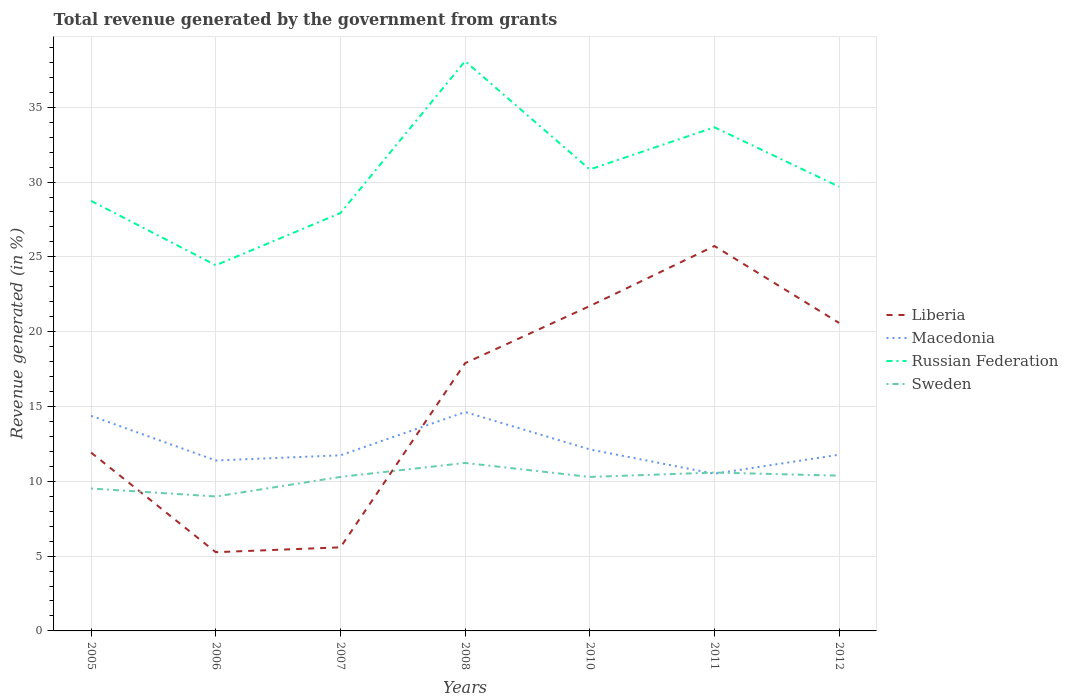Does the line corresponding to Sweden intersect with the line corresponding to Macedonia?
Keep it short and to the point. Yes. Is the number of lines equal to the number of legend labels?
Provide a short and direct response. Yes. Across all years, what is the maximum total revenue generated in Liberia?
Provide a short and direct response. 5.26. What is the total total revenue generated in Macedonia in the graph?
Ensure brevity in your answer.  1.63. What is the difference between the highest and the second highest total revenue generated in Sweden?
Offer a terse response. 2.24. How many lines are there?
Offer a very short reply. 4. What is the difference between two consecutive major ticks on the Y-axis?
Offer a very short reply. 5. Does the graph contain any zero values?
Make the answer very short. No. Does the graph contain grids?
Your response must be concise. Yes. Where does the legend appear in the graph?
Make the answer very short. Center right. How are the legend labels stacked?
Offer a terse response. Vertical. What is the title of the graph?
Ensure brevity in your answer.  Total revenue generated by the government from grants. What is the label or title of the Y-axis?
Offer a very short reply. Revenue generated (in %). What is the Revenue generated (in %) in Liberia in 2005?
Offer a very short reply. 11.92. What is the Revenue generated (in %) in Macedonia in 2005?
Make the answer very short. 14.38. What is the Revenue generated (in %) in Russian Federation in 2005?
Provide a short and direct response. 28.74. What is the Revenue generated (in %) in Sweden in 2005?
Keep it short and to the point. 9.52. What is the Revenue generated (in %) in Liberia in 2006?
Provide a short and direct response. 5.26. What is the Revenue generated (in %) of Macedonia in 2006?
Keep it short and to the point. 11.39. What is the Revenue generated (in %) in Russian Federation in 2006?
Keep it short and to the point. 24.44. What is the Revenue generated (in %) of Sweden in 2006?
Make the answer very short. 8.99. What is the Revenue generated (in %) of Liberia in 2007?
Offer a very short reply. 5.59. What is the Revenue generated (in %) of Macedonia in 2007?
Make the answer very short. 11.74. What is the Revenue generated (in %) of Russian Federation in 2007?
Keep it short and to the point. 27.93. What is the Revenue generated (in %) of Sweden in 2007?
Offer a very short reply. 10.29. What is the Revenue generated (in %) of Liberia in 2008?
Provide a short and direct response. 17.9. What is the Revenue generated (in %) of Macedonia in 2008?
Your response must be concise. 14.63. What is the Revenue generated (in %) in Russian Federation in 2008?
Provide a short and direct response. 38.08. What is the Revenue generated (in %) in Sweden in 2008?
Give a very brief answer. 11.23. What is the Revenue generated (in %) in Liberia in 2010?
Your answer should be compact. 21.71. What is the Revenue generated (in %) of Macedonia in 2010?
Give a very brief answer. 12.13. What is the Revenue generated (in %) of Russian Federation in 2010?
Ensure brevity in your answer.  30.84. What is the Revenue generated (in %) in Sweden in 2010?
Offer a terse response. 10.29. What is the Revenue generated (in %) of Liberia in 2011?
Provide a succinct answer. 25.73. What is the Revenue generated (in %) of Macedonia in 2011?
Provide a short and direct response. 10.51. What is the Revenue generated (in %) of Russian Federation in 2011?
Make the answer very short. 33.66. What is the Revenue generated (in %) in Sweden in 2011?
Make the answer very short. 10.59. What is the Revenue generated (in %) of Liberia in 2012?
Make the answer very short. 20.58. What is the Revenue generated (in %) of Macedonia in 2012?
Offer a very short reply. 11.78. What is the Revenue generated (in %) of Russian Federation in 2012?
Your response must be concise. 29.69. What is the Revenue generated (in %) of Sweden in 2012?
Your answer should be very brief. 10.38. Across all years, what is the maximum Revenue generated (in %) in Liberia?
Provide a succinct answer. 25.73. Across all years, what is the maximum Revenue generated (in %) of Macedonia?
Offer a terse response. 14.63. Across all years, what is the maximum Revenue generated (in %) of Russian Federation?
Your answer should be very brief. 38.08. Across all years, what is the maximum Revenue generated (in %) of Sweden?
Your answer should be compact. 11.23. Across all years, what is the minimum Revenue generated (in %) of Liberia?
Give a very brief answer. 5.26. Across all years, what is the minimum Revenue generated (in %) in Macedonia?
Ensure brevity in your answer.  10.51. Across all years, what is the minimum Revenue generated (in %) of Russian Federation?
Offer a very short reply. 24.44. Across all years, what is the minimum Revenue generated (in %) in Sweden?
Provide a succinct answer. 8.99. What is the total Revenue generated (in %) in Liberia in the graph?
Offer a terse response. 108.69. What is the total Revenue generated (in %) of Macedonia in the graph?
Provide a short and direct response. 86.55. What is the total Revenue generated (in %) of Russian Federation in the graph?
Give a very brief answer. 213.39. What is the total Revenue generated (in %) of Sweden in the graph?
Provide a short and direct response. 71.28. What is the difference between the Revenue generated (in %) of Liberia in 2005 and that in 2006?
Make the answer very short. 6.66. What is the difference between the Revenue generated (in %) of Macedonia in 2005 and that in 2006?
Provide a short and direct response. 2.98. What is the difference between the Revenue generated (in %) in Russian Federation in 2005 and that in 2006?
Offer a very short reply. 4.3. What is the difference between the Revenue generated (in %) in Sweden in 2005 and that in 2006?
Offer a very short reply. 0.53. What is the difference between the Revenue generated (in %) of Liberia in 2005 and that in 2007?
Provide a short and direct response. 6.33. What is the difference between the Revenue generated (in %) of Macedonia in 2005 and that in 2007?
Provide a short and direct response. 2.64. What is the difference between the Revenue generated (in %) in Russian Federation in 2005 and that in 2007?
Provide a succinct answer. 0.82. What is the difference between the Revenue generated (in %) of Sweden in 2005 and that in 2007?
Your answer should be very brief. -0.78. What is the difference between the Revenue generated (in %) of Liberia in 2005 and that in 2008?
Make the answer very short. -5.98. What is the difference between the Revenue generated (in %) in Macedonia in 2005 and that in 2008?
Offer a terse response. -0.25. What is the difference between the Revenue generated (in %) in Russian Federation in 2005 and that in 2008?
Your response must be concise. -9.34. What is the difference between the Revenue generated (in %) of Sweden in 2005 and that in 2008?
Your answer should be compact. -1.71. What is the difference between the Revenue generated (in %) of Liberia in 2005 and that in 2010?
Offer a very short reply. -9.8. What is the difference between the Revenue generated (in %) in Macedonia in 2005 and that in 2010?
Provide a succinct answer. 2.24. What is the difference between the Revenue generated (in %) in Russian Federation in 2005 and that in 2010?
Your answer should be compact. -2.1. What is the difference between the Revenue generated (in %) of Sweden in 2005 and that in 2010?
Ensure brevity in your answer.  -0.77. What is the difference between the Revenue generated (in %) of Liberia in 2005 and that in 2011?
Provide a short and direct response. -13.81. What is the difference between the Revenue generated (in %) in Macedonia in 2005 and that in 2011?
Ensure brevity in your answer.  3.87. What is the difference between the Revenue generated (in %) in Russian Federation in 2005 and that in 2011?
Keep it short and to the point. -4.92. What is the difference between the Revenue generated (in %) in Sweden in 2005 and that in 2011?
Make the answer very short. -1.07. What is the difference between the Revenue generated (in %) of Liberia in 2005 and that in 2012?
Provide a short and direct response. -8.66. What is the difference between the Revenue generated (in %) in Macedonia in 2005 and that in 2012?
Ensure brevity in your answer.  2.6. What is the difference between the Revenue generated (in %) in Russian Federation in 2005 and that in 2012?
Keep it short and to the point. -0.94. What is the difference between the Revenue generated (in %) of Sweden in 2005 and that in 2012?
Offer a very short reply. -0.86. What is the difference between the Revenue generated (in %) of Liberia in 2006 and that in 2007?
Keep it short and to the point. -0.33. What is the difference between the Revenue generated (in %) in Macedonia in 2006 and that in 2007?
Your answer should be compact. -0.35. What is the difference between the Revenue generated (in %) of Russian Federation in 2006 and that in 2007?
Provide a succinct answer. -3.49. What is the difference between the Revenue generated (in %) in Sweden in 2006 and that in 2007?
Offer a very short reply. -1.31. What is the difference between the Revenue generated (in %) of Liberia in 2006 and that in 2008?
Provide a short and direct response. -12.63. What is the difference between the Revenue generated (in %) in Macedonia in 2006 and that in 2008?
Keep it short and to the point. -3.24. What is the difference between the Revenue generated (in %) in Russian Federation in 2006 and that in 2008?
Ensure brevity in your answer.  -13.64. What is the difference between the Revenue generated (in %) of Sweden in 2006 and that in 2008?
Provide a succinct answer. -2.24. What is the difference between the Revenue generated (in %) of Liberia in 2006 and that in 2010?
Your answer should be compact. -16.45. What is the difference between the Revenue generated (in %) of Macedonia in 2006 and that in 2010?
Provide a short and direct response. -0.74. What is the difference between the Revenue generated (in %) of Russian Federation in 2006 and that in 2010?
Ensure brevity in your answer.  -6.4. What is the difference between the Revenue generated (in %) in Sweden in 2006 and that in 2010?
Make the answer very short. -1.31. What is the difference between the Revenue generated (in %) in Liberia in 2006 and that in 2011?
Ensure brevity in your answer.  -20.46. What is the difference between the Revenue generated (in %) of Macedonia in 2006 and that in 2011?
Ensure brevity in your answer.  0.89. What is the difference between the Revenue generated (in %) of Russian Federation in 2006 and that in 2011?
Your answer should be compact. -9.22. What is the difference between the Revenue generated (in %) of Sweden in 2006 and that in 2011?
Offer a very short reply. -1.6. What is the difference between the Revenue generated (in %) of Liberia in 2006 and that in 2012?
Ensure brevity in your answer.  -15.32. What is the difference between the Revenue generated (in %) in Macedonia in 2006 and that in 2012?
Your answer should be compact. -0.39. What is the difference between the Revenue generated (in %) in Russian Federation in 2006 and that in 2012?
Provide a short and direct response. -5.25. What is the difference between the Revenue generated (in %) in Sweden in 2006 and that in 2012?
Make the answer very short. -1.39. What is the difference between the Revenue generated (in %) of Liberia in 2007 and that in 2008?
Give a very brief answer. -12.31. What is the difference between the Revenue generated (in %) in Macedonia in 2007 and that in 2008?
Provide a succinct answer. -2.89. What is the difference between the Revenue generated (in %) in Russian Federation in 2007 and that in 2008?
Keep it short and to the point. -10.16. What is the difference between the Revenue generated (in %) in Sweden in 2007 and that in 2008?
Provide a short and direct response. -0.93. What is the difference between the Revenue generated (in %) of Liberia in 2007 and that in 2010?
Provide a short and direct response. -16.13. What is the difference between the Revenue generated (in %) of Macedonia in 2007 and that in 2010?
Offer a very short reply. -0.39. What is the difference between the Revenue generated (in %) of Russian Federation in 2007 and that in 2010?
Offer a terse response. -2.92. What is the difference between the Revenue generated (in %) in Sweden in 2007 and that in 2010?
Your answer should be very brief. 0. What is the difference between the Revenue generated (in %) in Liberia in 2007 and that in 2011?
Ensure brevity in your answer.  -20.14. What is the difference between the Revenue generated (in %) in Macedonia in 2007 and that in 2011?
Make the answer very short. 1.23. What is the difference between the Revenue generated (in %) of Russian Federation in 2007 and that in 2011?
Offer a terse response. -5.73. What is the difference between the Revenue generated (in %) in Sweden in 2007 and that in 2011?
Keep it short and to the point. -0.29. What is the difference between the Revenue generated (in %) of Liberia in 2007 and that in 2012?
Offer a very short reply. -15. What is the difference between the Revenue generated (in %) in Macedonia in 2007 and that in 2012?
Your response must be concise. -0.04. What is the difference between the Revenue generated (in %) of Russian Federation in 2007 and that in 2012?
Your response must be concise. -1.76. What is the difference between the Revenue generated (in %) of Sweden in 2007 and that in 2012?
Offer a very short reply. -0.08. What is the difference between the Revenue generated (in %) of Liberia in 2008 and that in 2010?
Provide a succinct answer. -3.82. What is the difference between the Revenue generated (in %) of Macedonia in 2008 and that in 2010?
Keep it short and to the point. 2.5. What is the difference between the Revenue generated (in %) in Russian Federation in 2008 and that in 2010?
Keep it short and to the point. 7.24. What is the difference between the Revenue generated (in %) of Sweden in 2008 and that in 2010?
Offer a terse response. 0.94. What is the difference between the Revenue generated (in %) in Liberia in 2008 and that in 2011?
Ensure brevity in your answer.  -7.83. What is the difference between the Revenue generated (in %) of Macedonia in 2008 and that in 2011?
Provide a succinct answer. 4.12. What is the difference between the Revenue generated (in %) of Russian Federation in 2008 and that in 2011?
Make the answer very short. 4.42. What is the difference between the Revenue generated (in %) in Sweden in 2008 and that in 2011?
Keep it short and to the point. 0.64. What is the difference between the Revenue generated (in %) in Liberia in 2008 and that in 2012?
Make the answer very short. -2.69. What is the difference between the Revenue generated (in %) in Macedonia in 2008 and that in 2012?
Offer a very short reply. 2.85. What is the difference between the Revenue generated (in %) in Russian Federation in 2008 and that in 2012?
Your answer should be very brief. 8.4. What is the difference between the Revenue generated (in %) of Liberia in 2010 and that in 2011?
Keep it short and to the point. -4.01. What is the difference between the Revenue generated (in %) of Macedonia in 2010 and that in 2011?
Offer a very short reply. 1.63. What is the difference between the Revenue generated (in %) of Russian Federation in 2010 and that in 2011?
Your answer should be very brief. -2.82. What is the difference between the Revenue generated (in %) of Sweden in 2010 and that in 2011?
Keep it short and to the point. -0.29. What is the difference between the Revenue generated (in %) of Liberia in 2010 and that in 2012?
Keep it short and to the point. 1.13. What is the difference between the Revenue generated (in %) of Macedonia in 2010 and that in 2012?
Your answer should be compact. 0.35. What is the difference between the Revenue generated (in %) of Russian Federation in 2010 and that in 2012?
Keep it short and to the point. 1.16. What is the difference between the Revenue generated (in %) in Sweden in 2010 and that in 2012?
Offer a very short reply. -0.09. What is the difference between the Revenue generated (in %) of Liberia in 2011 and that in 2012?
Your answer should be compact. 5.14. What is the difference between the Revenue generated (in %) in Macedonia in 2011 and that in 2012?
Ensure brevity in your answer.  -1.27. What is the difference between the Revenue generated (in %) in Russian Federation in 2011 and that in 2012?
Provide a short and direct response. 3.98. What is the difference between the Revenue generated (in %) in Sweden in 2011 and that in 2012?
Your response must be concise. 0.21. What is the difference between the Revenue generated (in %) in Liberia in 2005 and the Revenue generated (in %) in Macedonia in 2006?
Offer a very short reply. 0.53. What is the difference between the Revenue generated (in %) in Liberia in 2005 and the Revenue generated (in %) in Russian Federation in 2006?
Offer a terse response. -12.52. What is the difference between the Revenue generated (in %) of Liberia in 2005 and the Revenue generated (in %) of Sweden in 2006?
Provide a short and direct response. 2.93. What is the difference between the Revenue generated (in %) of Macedonia in 2005 and the Revenue generated (in %) of Russian Federation in 2006?
Make the answer very short. -10.06. What is the difference between the Revenue generated (in %) in Macedonia in 2005 and the Revenue generated (in %) in Sweden in 2006?
Offer a terse response. 5.39. What is the difference between the Revenue generated (in %) of Russian Federation in 2005 and the Revenue generated (in %) of Sweden in 2006?
Your answer should be very brief. 19.76. What is the difference between the Revenue generated (in %) of Liberia in 2005 and the Revenue generated (in %) of Macedonia in 2007?
Make the answer very short. 0.18. What is the difference between the Revenue generated (in %) in Liberia in 2005 and the Revenue generated (in %) in Russian Federation in 2007?
Give a very brief answer. -16.01. What is the difference between the Revenue generated (in %) in Liberia in 2005 and the Revenue generated (in %) in Sweden in 2007?
Provide a short and direct response. 1.63. What is the difference between the Revenue generated (in %) in Macedonia in 2005 and the Revenue generated (in %) in Russian Federation in 2007?
Offer a very short reply. -13.55. What is the difference between the Revenue generated (in %) of Macedonia in 2005 and the Revenue generated (in %) of Sweden in 2007?
Provide a succinct answer. 4.08. What is the difference between the Revenue generated (in %) of Russian Federation in 2005 and the Revenue generated (in %) of Sweden in 2007?
Provide a succinct answer. 18.45. What is the difference between the Revenue generated (in %) in Liberia in 2005 and the Revenue generated (in %) in Macedonia in 2008?
Make the answer very short. -2.71. What is the difference between the Revenue generated (in %) of Liberia in 2005 and the Revenue generated (in %) of Russian Federation in 2008?
Offer a very short reply. -26.16. What is the difference between the Revenue generated (in %) of Liberia in 2005 and the Revenue generated (in %) of Sweden in 2008?
Your response must be concise. 0.69. What is the difference between the Revenue generated (in %) in Macedonia in 2005 and the Revenue generated (in %) in Russian Federation in 2008?
Your answer should be compact. -23.71. What is the difference between the Revenue generated (in %) in Macedonia in 2005 and the Revenue generated (in %) in Sweden in 2008?
Provide a short and direct response. 3.15. What is the difference between the Revenue generated (in %) of Russian Federation in 2005 and the Revenue generated (in %) of Sweden in 2008?
Offer a very short reply. 17.52. What is the difference between the Revenue generated (in %) of Liberia in 2005 and the Revenue generated (in %) of Macedonia in 2010?
Provide a short and direct response. -0.21. What is the difference between the Revenue generated (in %) of Liberia in 2005 and the Revenue generated (in %) of Russian Federation in 2010?
Give a very brief answer. -18.93. What is the difference between the Revenue generated (in %) in Liberia in 2005 and the Revenue generated (in %) in Sweden in 2010?
Your response must be concise. 1.63. What is the difference between the Revenue generated (in %) of Macedonia in 2005 and the Revenue generated (in %) of Russian Federation in 2010?
Give a very brief answer. -16.47. What is the difference between the Revenue generated (in %) in Macedonia in 2005 and the Revenue generated (in %) in Sweden in 2010?
Your response must be concise. 4.08. What is the difference between the Revenue generated (in %) of Russian Federation in 2005 and the Revenue generated (in %) of Sweden in 2010?
Your answer should be compact. 18.45. What is the difference between the Revenue generated (in %) in Liberia in 2005 and the Revenue generated (in %) in Macedonia in 2011?
Provide a succinct answer. 1.41. What is the difference between the Revenue generated (in %) of Liberia in 2005 and the Revenue generated (in %) of Russian Federation in 2011?
Give a very brief answer. -21.74. What is the difference between the Revenue generated (in %) of Liberia in 2005 and the Revenue generated (in %) of Sweden in 2011?
Offer a very short reply. 1.33. What is the difference between the Revenue generated (in %) in Macedonia in 2005 and the Revenue generated (in %) in Russian Federation in 2011?
Offer a terse response. -19.29. What is the difference between the Revenue generated (in %) of Macedonia in 2005 and the Revenue generated (in %) of Sweden in 2011?
Give a very brief answer. 3.79. What is the difference between the Revenue generated (in %) in Russian Federation in 2005 and the Revenue generated (in %) in Sweden in 2011?
Your response must be concise. 18.16. What is the difference between the Revenue generated (in %) in Liberia in 2005 and the Revenue generated (in %) in Macedonia in 2012?
Your response must be concise. 0.14. What is the difference between the Revenue generated (in %) in Liberia in 2005 and the Revenue generated (in %) in Russian Federation in 2012?
Offer a terse response. -17.77. What is the difference between the Revenue generated (in %) in Liberia in 2005 and the Revenue generated (in %) in Sweden in 2012?
Your answer should be compact. 1.54. What is the difference between the Revenue generated (in %) in Macedonia in 2005 and the Revenue generated (in %) in Russian Federation in 2012?
Offer a terse response. -15.31. What is the difference between the Revenue generated (in %) in Macedonia in 2005 and the Revenue generated (in %) in Sweden in 2012?
Offer a terse response. 4. What is the difference between the Revenue generated (in %) of Russian Federation in 2005 and the Revenue generated (in %) of Sweden in 2012?
Keep it short and to the point. 18.37. What is the difference between the Revenue generated (in %) of Liberia in 2006 and the Revenue generated (in %) of Macedonia in 2007?
Give a very brief answer. -6.48. What is the difference between the Revenue generated (in %) of Liberia in 2006 and the Revenue generated (in %) of Russian Federation in 2007?
Your response must be concise. -22.67. What is the difference between the Revenue generated (in %) in Liberia in 2006 and the Revenue generated (in %) in Sweden in 2007?
Provide a short and direct response. -5.03. What is the difference between the Revenue generated (in %) in Macedonia in 2006 and the Revenue generated (in %) in Russian Federation in 2007?
Your response must be concise. -16.54. What is the difference between the Revenue generated (in %) in Macedonia in 2006 and the Revenue generated (in %) in Sweden in 2007?
Offer a very short reply. 1.1. What is the difference between the Revenue generated (in %) of Russian Federation in 2006 and the Revenue generated (in %) of Sweden in 2007?
Make the answer very short. 14.15. What is the difference between the Revenue generated (in %) of Liberia in 2006 and the Revenue generated (in %) of Macedonia in 2008?
Your answer should be compact. -9.37. What is the difference between the Revenue generated (in %) of Liberia in 2006 and the Revenue generated (in %) of Russian Federation in 2008?
Provide a short and direct response. -32.82. What is the difference between the Revenue generated (in %) of Liberia in 2006 and the Revenue generated (in %) of Sweden in 2008?
Your response must be concise. -5.97. What is the difference between the Revenue generated (in %) in Macedonia in 2006 and the Revenue generated (in %) in Russian Federation in 2008?
Ensure brevity in your answer.  -26.69. What is the difference between the Revenue generated (in %) of Macedonia in 2006 and the Revenue generated (in %) of Sweden in 2008?
Your answer should be very brief. 0.16. What is the difference between the Revenue generated (in %) of Russian Federation in 2006 and the Revenue generated (in %) of Sweden in 2008?
Your response must be concise. 13.21. What is the difference between the Revenue generated (in %) of Liberia in 2006 and the Revenue generated (in %) of Macedonia in 2010?
Offer a terse response. -6.87. What is the difference between the Revenue generated (in %) of Liberia in 2006 and the Revenue generated (in %) of Russian Federation in 2010?
Your answer should be very brief. -25.58. What is the difference between the Revenue generated (in %) of Liberia in 2006 and the Revenue generated (in %) of Sweden in 2010?
Provide a succinct answer. -5.03. What is the difference between the Revenue generated (in %) in Macedonia in 2006 and the Revenue generated (in %) in Russian Federation in 2010?
Offer a terse response. -19.45. What is the difference between the Revenue generated (in %) in Macedonia in 2006 and the Revenue generated (in %) in Sweden in 2010?
Provide a short and direct response. 1.1. What is the difference between the Revenue generated (in %) in Russian Federation in 2006 and the Revenue generated (in %) in Sweden in 2010?
Ensure brevity in your answer.  14.15. What is the difference between the Revenue generated (in %) of Liberia in 2006 and the Revenue generated (in %) of Macedonia in 2011?
Offer a very short reply. -5.24. What is the difference between the Revenue generated (in %) in Liberia in 2006 and the Revenue generated (in %) in Russian Federation in 2011?
Keep it short and to the point. -28.4. What is the difference between the Revenue generated (in %) of Liberia in 2006 and the Revenue generated (in %) of Sweden in 2011?
Your answer should be very brief. -5.32. What is the difference between the Revenue generated (in %) of Macedonia in 2006 and the Revenue generated (in %) of Russian Federation in 2011?
Your answer should be very brief. -22.27. What is the difference between the Revenue generated (in %) in Macedonia in 2006 and the Revenue generated (in %) in Sweden in 2011?
Make the answer very short. 0.81. What is the difference between the Revenue generated (in %) of Russian Federation in 2006 and the Revenue generated (in %) of Sweden in 2011?
Give a very brief answer. 13.86. What is the difference between the Revenue generated (in %) of Liberia in 2006 and the Revenue generated (in %) of Macedonia in 2012?
Ensure brevity in your answer.  -6.52. What is the difference between the Revenue generated (in %) in Liberia in 2006 and the Revenue generated (in %) in Russian Federation in 2012?
Give a very brief answer. -24.42. What is the difference between the Revenue generated (in %) in Liberia in 2006 and the Revenue generated (in %) in Sweden in 2012?
Your answer should be very brief. -5.12. What is the difference between the Revenue generated (in %) of Macedonia in 2006 and the Revenue generated (in %) of Russian Federation in 2012?
Offer a terse response. -18.29. What is the difference between the Revenue generated (in %) of Macedonia in 2006 and the Revenue generated (in %) of Sweden in 2012?
Offer a terse response. 1.01. What is the difference between the Revenue generated (in %) in Russian Federation in 2006 and the Revenue generated (in %) in Sweden in 2012?
Offer a terse response. 14.06. What is the difference between the Revenue generated (in %) of Liberia in 2007 and the Revenue generated (in %) of Macedonia in 2008?
Provide a succinct answer. -9.04. What is the difference between the Revenue generated (in %) of Liberia in 2007 and the Revenue generated (in %) of Russian Federation in 2008?
Offer a terse response. -32.5. What is the difference between the Revenue generated (in %) in Liberia in 2007 and the Revenue generated (in %) in Sweden in 2008?
Make the answer very short. -5.64. What is the difference between the Revenue generated (in %) of Macedonia in 2007 and the Revenue generated (in %) of Russian Federation in 2008?
Your answer should be very brief. -26.35. What is the difference between the Revenue generated (in %) of Macedonia in 2007 and the Revenue generated (in %) of Sweden in 2008?
Your response must be concise. 0.51. What is the difference between the Revenue generated (in %) in Russian Federation in 2007 and the Revenue generated (in %) in Sweden in 2008?
Make the answer very short. 16.7. What is the difference between the Revenue generated (in %) of Liberia in 2007 and the Revenue generated (in %) of Macedonia in 2010?
Your answer should be very brief. -6.54. What is the difference between the Revenue generated (in %) in Liberia in 2007 and the Revenue generated (in %) in Russian Federation in 2010?
Your response must be concise. -25.26. What is the difference between the Revenue generated (in %) in Liberia in 2007 and the Revenue generated (in %) in Sweden in 2010?
Your answer should be very brief. -4.7. What is the difference between the Revenue generated (in %) in Macedonia in 2007 and the Revenue generated (in %) in Russian Federation in 2010?
Your answer should be very brief. -19.11. What is the difference between the Revenue generated (in %) of Macedonia in 2007 and the Revenue generated (in %) of Sweden in 2010?
Make the answer very short. 1.45. What is the difference between the Revenue generated (in %) of Russian Federation in 2007 and the Revenue generated (in %) of Sweden in 2010?
Offer a very short reply. 17.64. What is the difference between the Revenue generated (in %) of Liberia in 2007 and the Revenue generated (in %) of Macedonia in 2011?
Give a very brief answer. -4.92. What is the difference between the Revenue generated (in %) in Liberia in 2007 and the Revenue generated (in %) in Russian Federation in 2011?
Provide a succinct answer. -28.08. What is the difference between the Revenue generated (in %) in Liberia in 2007 and the Revenue generated (in %) in Sweden in 2011?
Your response must be concise. -5. What is the difference between the Revenue generated (in %) in Macedonia in 2007 and the Revenue generated (in %) in Russian Federation in 2011?
Your response must be concise. -21.93. What is the difference between the Revenue generated (in %) of Macedonia in 2007 and the Revenue generated (in %) of Sweden in 2011?
Give a very brief answer. 1.15. What is the difference between the Revenue generated (in %) of Russian Federation in 2007 and the Revenue generated (in %) of Sweden in 2011?
Provide a succinct answer. 17.34. What is the difference between the Revenue generated (in %) of Liberia in 2007 and the Revenue generated (in %) of Macedonia in 2012?
Provide a short and direct response. -6.19. What is the difference between the Revenue generated (in %) of Liberia in 2007 and the Revenue generated (in %) of Russian Federation in 2012?
Make the answer very short. -24.1. What is the difference between the Revenue generated (in %) in Liberia in 2007 and the Revenue generated (in %) in Sweden in 2012?
Give a very brief answer. -4.79. What is the difference between the Revenue generated (in %) in Macedonia in 2007 and the Revenue generated (in %) in Russian Federation in 2012?
Keep it short and to the point. -17.95. What is the difference between the Revenue generated (in %) in Macedonia in 2007 and the Revenue generated (in %) in Sweden in 2012?
Make the answer very short. 1.36. What is the difference between the Revenue generated (in %) in Russian Federation in 2007 and the Revenue generated (in %) in Sweden in 2012?
Ensure brevity in your answer.  17.55. What is the difference between the Revenue generated (in %) in Liberia in 2008 and the Revenue generated (in %) in Macedonia in 2010?
Your answer should be very brief. 5.76. What is the difference between the Revenue generated (in %) of Liberia in 2008 and the Revenue generated (in %) of Russian Federation in 2010?
Your response must be concise. -12.95. What is the difference between the Revenue generated (in %) in Liberia in 2008 and the Revenue generated (in %) in Sweden in 2010?
Offer a very short reply. 7.61. What is the difference between the Revenue generated (in %) in Macedonia in 2008 and the Revenue generated (in %) in Russian Federation in 2010?
Make the answer very short. -16.21. What is the difference between the Revenue generated (in %) of Macedonia in 2008 and the Revenue generated (in %) of Sweden in 2010?
Your answer should be compact. 4.34. What is the difference between the Revenue generated (in %) of Russian Federation in 2008 and the Revenue generated (in %) of Sweden in 2010?
Ensure brevity in your answer.  27.79. What is the difference between the Revenue generated (in %) of Liberia in 2008 and the Revenue generated (in %) of Macedonia in 2011?
Offer a terse response. 7.39. What is the difference between the Revenue generated (in %) of Liberia in 2008 and the Revenue generated (in %) of Russian Federation in 2011?
Make the answer very short. -15.77. What is the difference between the Revenue generated (in %) in Liberia in 2008 and the Revenue generated (in %) in Sweden in 2011?
Provide a succinct answer. 7.31. What is the difference between the Revenue generated (in %) of Macedonia in 2008 and the Revenue generated (in %) of Russian Federation in 2011?
Offer a very short reply. -19.03. What is the difference between the Revenue generated (in %) in Macedonia in 2008 and the Revenue generated (in %) in Sweden in 2011?
Make the answer very short. 4.05. What is the difference between the Revenue generated (in %) of Russian Federation in 2008 and the Revenue generated (in %) of Sweden in 2011?
Keep it short and to the point. 27.5. What is the difference between the Revenue generated (in %) in Liberia in 2008 and the Revenue generated (in %) in Macedonia in 2012?
Offer a very short reply. 6.12. What is the difference between the Revenue generated (in %) of Liberia in 2008 and the Revenue generated (in %) of Russian Federation in 2012?
Provide a succinct answer. -11.79. What is the difference between the Revenue generated (in %) in Liberia in 2008 and the Revenue generated (in %) in Sweden in 2012?
Your response must be concise. 7.52. What is the difference between the Revenue generated (in %) of Macedonia in 2008 and the Revenue generated (in %) of Russian Federation in 2012?
Offer a terse response. -15.06. What is the difference between the Revenue generated (in %) of Macedonia in 2008 and the Revenue generated (in %) of Sweden in 2012?
Give a very brief answer. 4.25. What is the difference between the Revenue generated (in %) in Russian Federation in 2008 and the Revenue generated (in %) in Sweden in 2012?
Provide a short and direct response. 27.71. What is the difference between the Revenue generated (in %) in Liberia in 2010 and the Revenue generated (in %) in Macedonia in 2011?
Provide a succinct answer. 11.21. What is the difference between the Revenue generated (in %) of Liberia in 2010 and the Revenue generated (in %) of Russian Federation in 2011?
Ensure brevity in your answer.  -11.95. What is the difference between the Revenue generated (in %) of Liberia in 2010 and the Revenue generated (in %) of Sweden in 2011?
Give a very brief answer. 11.13. What is the difference between the Revenue generated (in %) of Macedonia in 2010 and the Revenue generated (in %) of Russian Federation in 2011?
Provide a short and direct response. -21.53. What is the difference between the Revenue generated (in %) in Macedonia in 2010 and the Revenue generated (in %) in Sweden in 2011?
Provide a succinct answer. 1.55. What is the difference between the Revenue generated (in %) of Russian Federation in 2010 and the Revenue generated (in %) of Sweden in 2011?
Provide a short and direct response. 20.26. What is the difference between the Revenue generated (in %) of Liberia in 2010 and the Revenue generated (in %) of Macedonia in 2012?
Keep it short and to the point. 9.94. What is the difference between the Revenue generated (in %) of Liberia in 2010 and the Revenue generated (in %) of Russian Federation in 2012?
Your answer should be compact. -7.97. What is the difference between the Revenue generated (in %) in Liberia in 2010 and the Revenue generated (in %) in Sweden in 2012?
Make the answer very short. 11.34. What is the difference between the Revenue generated (in %) in Macedonia in 2010 and the Revenue generated (in %) in Russian Federation in 2012?
Give a very brief answer. -17.56. What is the difference between the Revenue generated (in %) in Macedonia in 2010 and the Revenue generated (in %) in Sweden in 2012?
Give a very brief answer. 1.75. What is the difference between the Revenue generated (in %) in Russian Federation in 2010 and the Revenue generated (in %) in Sweden in 2012?
Provide a short and direct response. 20.47. What is the difference between the Revenue generated (in %) in Liberia in 2011 and the Revenue generated (in %) in Macedonia in 2012?
Offer a terse response. 13.95. What is the difference between the Revenue generated (in %) in Liberia in 2011 and the Revenue generated (in %) in Russian Federation in 2012?
Provide a short and direct response. -3.96. What is the difference between the Revenue generated (in %) of Liberia in 2011 and the Revenue generated (in %) of Sweden in 2012?
Your answer should be compact. 15.35. What is the difference between the Revenue generated (in %) of Macedonia in 2011 and the Revenue generated (in %) of Russian Federation in 2012?
Keep it short and to the point. -19.18. What is the difference between the Revenue generated (in %) in Macedonia in 2011 and the Revenue generated (in %) in Sweden in 2012?
Offer a very short reply. 0.13. What is the difference between the Revenue generated (in %) in Russian Federation in 2011 and the Revenue generated (in %) in Sweden in 2012?
Your answer should be compact. 23.29. What is the average Revenue generated (in %) in Liberia per year?
Keep it short and to the point. 15.53. What is the average Revenue generated (in %) in Macedonia per year?
Offer a terse response. 12.36. What is the average Revenue generated (in %) in Russian Federation per year?
Your answer should be compact. 30.48. What is the average Revenue generated (in %) of Sweden per year?
Provide a succinct answer. 10.18. In the year 2005, what is the difference between the Revenue generated (in %) of Liberia and Revenue generated (in %) of Macedonia?
Provide a succinct answer. -2.46. In the year 2005, what is the difference between the Revenue generated (in %) in Liberia and Revenue generated (in %) in Russian Federation?
Your response must be concise. -16.82. In the year 2005, what is the difference between the Revenue generated (in %) of Liberia and Revenue generated (in %) of Sweden?
Your response must be concise. 2.4. In the year 2005, what is the difference between the Revenue generated (in %) in Macedonia and Revenue generated (in %) in Russian Federation?
Your answer should be compact. -14.37. In the year 2005, what is the difference between the Revenue generated (in %) in Macedonia and Revenue generated (in %) in Sweden?
Provide a succinct answer. 4.86. In the year 2005, what is the difference between the Revenue generated (in %) in Russian Federation and Revenue generated (in %) in Sweden?
Keep it short and to the point. 19.23. In the year 2006, what is the difference between the Revenue generated (in %) in Liberia and Revenue generated (in %) in Macedonia?
Keep it short and to the point. -6.13. In the year 2006, what is the difference between the Revenue generated (in %) of Liberia and Revenue generated (in %) of Russian Federation?
Give a very brief answer. -19.18. In the year 2006, what is the difference between the Revenue generated (in %) of Liberia and Revenue generated (in %) of Sweden?
Give a very brief answer. -3.72. In the year 2006, what is the difference between the Revenue generated (in %) in Macedonia and Revenue generated (in %) in Russian Federation?
Provide a succinct answer. -13.05. In the year 2006, what is the difference between the Revenue generated (in %) of Macedonia and Revenue generated (in %) of Sweden?
Provide a succinct answer. 2.41. In the year 2006, what is the difference between the Revenue generated (in %) in Russian Federation and Revenue generated (in %) in Sweden?
Provide a short and direct response. 15.45. In the year 2007, what is the difference between the Revenue generated (in %) of Liberia and Revenue generated (in %) of Macedonia?
Provide a short and direct response. -6.15. In the year 2007, what is the difference between the Revenue generated (in %) of Liberia and Revenue generated (in %) of Russian Federation?
Ensure brevity in your answer.  -22.34. In the year 2007, what is the difference between the Revenue generated (in %) of Liberia and Revenue generated (in %) of Sweden?
Make the answer very short. -4.71. In the year 2007, what is the difference between the Revenue generated (in %) of Macedonia and Revenue generated (in %) of Russian Federation?
Keep it short and to the point. -16.19. In the year 2007, what is the difference between the Revenue generated (in %) of Macedonia and Revenue generated (in %) of Sweden?
Give a very brief answer. 1.44. In the year 2007, what is the difference between the Revenue generated (in %) of Russian Federation and Revenue generated (in %) of Sweden?
Make the answer very short. 17.63. In the year 2008, what is the difference between the Revenue generated (in %) in Liberia and Revenue generated (in %) in Macedonia?
Provide a short and direct response. 3.27. In the year 2008, what is the difference between the Revenue generated (in %) in Liberia and Revenue generated (in %) in Russian Federation?
Your answer should be very brief. -20.19. In the year 2008, what is the difference between the Revenue generated (in %) in Liberia and Revenue generated (in %) in Sweden?
Provide a short and direct response. 6.67. In the year 2008, what is the difference between the Revenue generated (in %) of Macedonia and Revenue generated (in %) of Russian Federation?
Offer a terse response. -23.45. In the year 2008, what is the difference between the Revenue generated (in %) of Macedonia and Revenue generated (in %) of Sweden?
Provide a short and direct response. 3.4. In the year 2008, what is the difference between the Revenue generated (in %) in Russian Federation and Revenue generated (in %) in Sweden?
Your answer should be very brief. 26.86. In the year 2010, what is the difference between the Revenue generated (in %) of Liberia and Revenue generated (in %) of Macedonia?
Keep it short and to the point. 9.58. In the year 2010, what is the difference between the Revenue generated (in %) of Liberia and Revenue generated (in %) of Russian Federation?
Your answer should be very brief. -9.13. In the year 2010, what is the difference between the Revenue generated (in %) of Liberia and Revenue generated (in %) of Sweden?
Offer a very short reply. 11.42. In the year 2010, what is the difference between the Revenue generated (in %) in Macedonia and Revenue generated (in %) in Russian Federation?
Provide a succinct answer. -18.71. In the year 2010, what is the difference between the Revenue generated (in %) of Macedonia and Revenue generated (in %) of Sweden?
Offer a very short reply. 1.84. In the year 2010, what is the difference between the Revenue generated (in %) in Russian Federation and Revenue generated (in %) in Sweden?
Make the answer very short. 20.55. In the year 2011, what is the difference between the Revenue generated (in %) of Liberia and Revenue generated (in %) of Macedonia?
Offer a very short reply. 15.22. In the year 2011, what is the difference between the Revenue generated (in %) in Liberia and Revenue generated (in %) in Russian Federation?
Make the answer very short. -7.94. In the year 2011, what is the difference between the Revenue generated (in %) of Liberia and Revenue generated (in %) of Sweden?
Keep it short and to the point. 15.14. In the year 2011, what is the difference between the Revenue generated (in %) of Macedonia and Revenue generated (in %) of Russian Federation?
Provide a short and direct response. -23.16. In the year 2011, what is the difference between the Revenue generated (in %) of Macedonia and Revenue generated (in %) of Sweden?
Make the answer very short. -0.08. In the year 2011, what is the difference between the Revenue generated (in %) in Russian Federation and Revenue generated (in %) in Sweden?
Offer a very short reply. 23.08. In the year 2012, what is the difference between the Revenue generated (in %) in Liberia and Revenue generated (in %) in Macedonia?
Offer a very short reply. 8.81. In the year 2012, what is the difference between the Revenue generated (in %) in Liberia and Revenue generated (in %) in Russian Federation?
Your response must be concise. -9.1. In the year 2012, what is the difference between the Revenue generated (in %) in Liberia and Revenue generated (in %) in Sweden?
Your response must be concise. 10.21. In the year 2012, what is the difference between the Revenue generated (in %) of Macedonia and Revenue generated (in %) of Russian Federation?
Offer a terse response. -17.91. In the year 2012, what is the difference between the Revenue generated (in %) in Macedonia and Revenue generated (in %) in Sweden?
Ensure brevity in your answer.  1.4. In the year 2012, what is the difference between the Revenue generated (in %) of Russian Federation and Revenue generated (in %) of Sweden?
Provide a short and direct response. 19.31. What is the ratio of the Revenue generated (in %) in Liberia in 2005 to that in 2006?
Offer a terse response. 2.27. What is the ratio of the Revenue generated (in %) of Macedonia in 2005 to that in 2006?
Your answer should be compact. 1.26. What is the ratio of the Revenue generated (in %) in Russian Federation in 2005 to that in 2006?
Provide a succinct answer. 1.18. What is the ratio of the Revenue generated (in %) in Sweden in 2005 to that in 2006?
Offer a terse response. 1.06. What is the ratio of the Revenue generated (in %) of Liberia in 2005 to that in 2007?
Your answer should be compact. 2.13. What is the ratio of the Revenue generated (in %) of Macedonia in 2005 to that in 2007?
Offer a terse response. 1.22. What is the ratio of the Revenue generated (in %) in Russian Federation in 2005 to that in 2007?
Provide a succinct answer. 1.03. What is the ratio of the Revenue generated (in %) of Sweden in 2005 to that in 2007?
Make the answer very short. 0.92. What is the ratio of the Revenue generated (in %) of Liberia in 2005 to that in 2008?
Your answer should be compact. 0.67. What is the ratio of the Revenue generated (in %) in Macedonia in 2005 to that in 2008?
Ensure brevity in your answer.  0.98. What is the ratio of the Revenue generated (in %) of Russian Federation in 2005 to that in 2008?
Provide a short and direct response. 0.75. What is the ratio of the Revenue generated (in %) in Sweden in 2005 to that in 2008?
Ensure brevity in your answer.  0.85. What is the ratio of the Revenue generated (in %) in Liberia in 2005 to that in 2010?
Offer a very short reply. 0.55. What is the ratio of the Revenue generated (in %) in Macedonia in 2005 to that in 2010?
Keep it short and to the point. 1.19. What is the ratio of the Revenue generated (in %) in Russian Federation in 2005 to that in 2010?
Provide a short and direct response. 0.93. What is the ratio of the Revenue generated (in %) in Sweden in 2005 to that in 2010?
Offer a very short reply. 0.92. What is the ratio of the Revenue generated (in %) in Liberia in 2005 to that in 2011?
Offer a very short reply. 0.46. What is the ratio of the Revenue generated (in %) of Macedonia in 2005 to that in 2011?
Provide a short and direct response. 1.37. What is the ratio of the Revenue generated (in %) in Russian Federation in 2005 to that in 2011?
Your response must be concise. 0.85. What is the ratio of the Revenue generated (in %) of Sweden in 2005 to that in 2011?
Offer a terse response. 0.9. What is the ratio of the Revenue generated (in %) in Liberia in 2005 to that in 2012?
Give a very brief answer. 0.58. What is the ratio of the Revenue generated (in %) of Macedonia in 2005 to that in 2012?
Provide a succinct answer. 1.22. What is the ratio of the Revenue generated (in %) of Russian Federation in 2005 to that in 2012?
Provide a short and direct response. 0.97. What is the ratio of the Revenue generated (in %) in Sweden in 2005 to that in 2012?
Your answer should be very brief. 0.92. What is the ratio of the Revenue generated (in %) of Liberia in 2006 to that in 2007?
Your answer should be compact. 0.94. What is the ratio of the Revenue generated (in %) in Macedonia in 2006 to that in 2007?
Offer a very short reply. 0.97. What is the ratio of the Revenue generated (in %) of Russian Federation in 2006 to that in 2007?
Your answer should be very brief. 0.88. What is the ratio of the Revenue generated (in %) of Sweden in 2006 to that in 2007?
Provide a succinct answer. 0.87. What is the ratio of the Revenue generated (in %) of Liberia in 2006 to that in 2008?
Provide a succinct answer. 0.29. What is the ratio of the Revenue generated (in %) in Macedonia in 2006 to that in 2008?
Keep it short and to the point. 0.78. What is the ratio of the Revenue generated (in %) in Russian Federation in 2006 to that in 2008?
Offer a very short reply. 0.64. What is the ratio of the Revenue generated (in %) in Sweden in 2006 to that in 2008?
Provide a succinct answer. 0.8. What is the ratio of the Revenue generated (in %) of Liberia in 2006 to that in 2010?
Provide a succinct answer. 0.24. What is the ratio of the Revenue generated (in %) of Macedonia in 2006 to that in 2010?
Offer a very short reply. 0.94. What is the ratio of the Revenue generated (in %) in Russian Federation in 2006 to that in 2010?
Your answer should be very brief. 0.79. What is the ratio of the Revenue generated (in %) in Sweden in 2006 to that in 2010?
Make the answer very short. 0.87. What is the ratio of the Revenue generated (in %) in Liberia in 2006 to that in 2011?
Provide a succinct answer. 0.2. What is the ratio of the Revenue generated (in %) in Macedonia in 2006 to that in 2011?
Make the answer very short. 1.08. What is the ratio of the Revenue generated (in %) of Russian Federation in 2006 to that in 2011?
Give a very brief answer. 0.73. What is the ratio of the Revenue generated (in %) of Sweden in 2006 to that in 2011?
Your response must be concise. 0.85. What is the ratio of the Revenue generated (in %) of Liberia in 2006 to that in 2012?
Ensure brevity in your answer.  0.26. What is the ratio of the Revenue generated (in %) of Macedonia in 2006 to that in 2012?
Offer a very short reply. 0.97. What is the ratio of the Revenue generated (in %) in Russian Federation in 2006 to that in 2012?
Your response must be concise. 0.82. What is the ratio of the Revenue generated (in %) in Sweden in 2006 to that in 2012?
Offer a terse response. 0.87. What is the ratio of the Revenue generated (in %) of Liberia in 2007 to that in 2008?
Your answer should be very brief. 0.31. What is the ratio of the Revenue generated (in %) of Macedonia in 2007 to that in 2008?
Ensure brevity in your answer.  0.8. What is the ratio of the Revenue generated (in %) of Russian Federation in 2007 to that in 2008?
Offer a terse response. 0.73. What is the ratio of the Revenue generated (in %) of Sweden in 2007 to that in 2008?
Offer a terse response. 0.92. What is the ratio of the Revenue generated (in %) in Liberia in 2007 to that in 2010?
Offer a terse response. 0.26. What is the ratio of the Revenue generated (in %) in Macedonia in 2007 to that in 2010?
Your answer should be very brief. 0.97. What is the ratio of the Revenue generated (in %) of Russian Federation in 2007 to that in 2010?
Provide a succinct answer. 0.91. What is the ratio of the Revenue generated (in %) of Sweden in 2007 to that in 2010?
Offer a very short reply. 1. What is the ratio of the Revenue generated (in %) in Liberia in 2007 to that in 2011?
Offer a terse response. 0.22. What is the ratio of the Revenue generated (in %) of Macedonia in 2007 to that in 2011?
Make the answer very short. 1.12. What is the ratio of the Revenue generated (in %) in Russian Federation in 2007 to that in 2011?
Your response must be concise. 0.83. What is the ratio of the Revenue generated (in %) in Sweden in 2007 to that in 2011?
Make the answer very short. 0.97. What is the ratio of the Revenue generated (in %) in Liberia in 2007 to that in 2012?
Keep it short and to the point. 0.27. What is the ratio of the Revenue generated (in %) in Russian Federation in 2007 to that in 2012?
Your response must be concise. 0.94. What is the ratio of the Revenue generated (in %) of Liberia in 2008 to that in 2010?
Provide a succinct answer. 0.82. What is the ratio of the Revenue generated (in %) of Macedonia in 2008 to that in 2010?
Provide a short and direct response. 1.21. What is the ratio of the Revenue generated (in %) in Russian Federation in 2008 to that in 2010?
Make the answer very short. 1.23. What is the ratio of the Revenue generated (in %) in Sweden in 2008 to that in 2010?
Make the answer very short. 1.09. What is the ratio of the Revenue generated (in %) of Liberia in 2008 to that in 2011?
Give a very brief answer. 0.7. What is the ratio of the Revenue generated (in %) of Macedonia in 2008 to that in 2011?
Offer a very short reply. 1.39. What is the ratio of the Revenue generated (in %) of Russian Federation in 2008 to that in 2011?
Make the answer very short. 1.13. What is the ratio of the Revenue generated (in %) of Sweden in 2008 to that in 2011?
Give a very brief answer. 1.06. What is the ratio of the Revenue generated (in %) of Liberia in 2008 to that in 2012?
Your response must be concise. 0.87. What is the ratio of the Revenue generated (in %) in Macedonia in 2008 to that in 2012?
Offer a very short reply. 1.24. What is the ratio of the Revenue generated (in %) of Russian Federation in 2008 to that in 2012?
Make the answer very short. 1.28. What is the ratio of the Revenue generated (in %) in Sweden in 2008 to that in 2012?
Give a very brief answer. 1.08. What is the ratio of the Revenue generated (in %) in Liberia in 2010 to that in 2011?
Give a very brief answer. 0.84. What is the ratio of the Revenue generated (in %) in Macedonia in 2010 to that in 2011?
Your answer should be compact. 1.15. What is the ratio of the Revenue generated (in %) in Russian Federation in 2010 to that in 2011?
Make the answer very short. 0.92. What is the ratio of the Revenue generated (in %) of Sweden in 2010 to that in 2011?
Provide a succinct answer. 0.97. What is the ratio of the Revenue generated (in %) in Liberia in 2010 to that in 2012?
Your response must be concise. 1.05. What is the ratio of the Revenue generated (in %) in Macedonia in 2010 to that in 2012?
Provide a short and direct response. 1.03. What is the ratio of the Revenue generated (in %) in Russian Federation in 2010 to that in 2012?
Make the answer very short. 1.04. What is the ratio of the Revenue generated (in %) in Liberia in 2011 to that in 2012?
Provide a short and direct response. 1.25. What is the ratio of the Revenue generated (in %) in Macedonia in 2011 to that in 2012?
Keep it short and to the point. 0.89. What is the ratio of the Revenue generated (in %) of Russian Federation in 2011 to that in 2012?
Make the answer very short. 1.13. What is the ratio of the Revenue generated (in %) in Sweden in 2011 to that in 2012?
Ensure brevity in your answer.  1.02. What is the difference between the highest and the second highest Revenue generated (in %) of Liberia?
Your answer should be compact. 4.01. What is the difference between the highest and the second highest Revenue generated (in %) in Macedonia?
Give a very brief answer. 0.25. What is the difference between the highest and the second highest Revenue generated (in %) in Russian Federation?
Your response must be concise. 4.42. What is the difference between the highest and the second highest Revenue generated (in %) of Sweden?
Your response must be concise. 0.64. What is the difference between the highest and the lowest Revenue generated (in %) of Liberia?
Offer a terse response. 20.46. What is the difference between the highest and the lowest Revenue generated (in %) in Macedonia?
Make the answer very short. 4.12. What is the difference between the highest and the lowest Revenue generated (in %) of Russian Federation?
Provide a succinct answer. 13.64. What is the difference between the highest and the lowest Revenue generated (in %) in Sweden?
Keep it short and to the point. 2.24. 